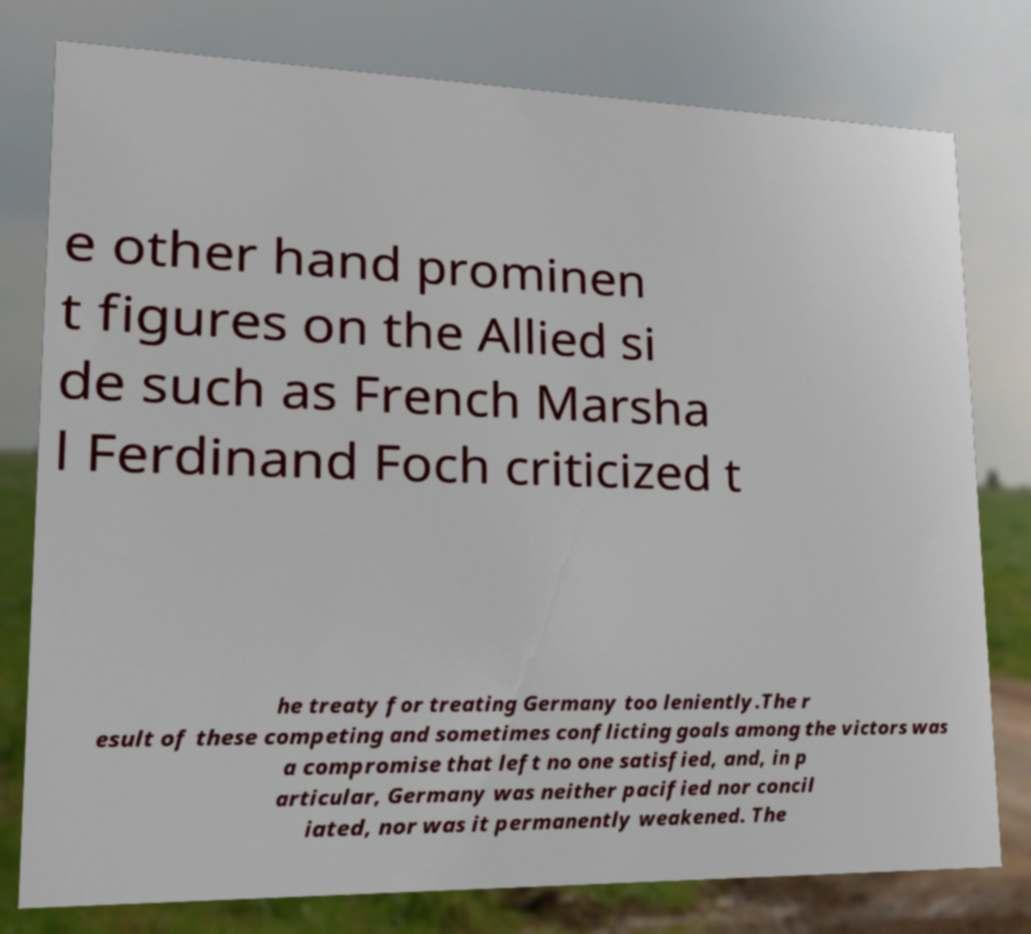Please identify and transcribe the text found in this image. e other hand prominen t figures on the Allied si de such as French Marsha l Ferdinand Foch criticized t he treaty for treating Germany too leniently.The r esult of these competing and sometimes conflicting goals among the victors was a compromise that left no one satisfied, and, in p articular, Germany was neither pacified nor concil iated, nor was it permanently weakened. The 